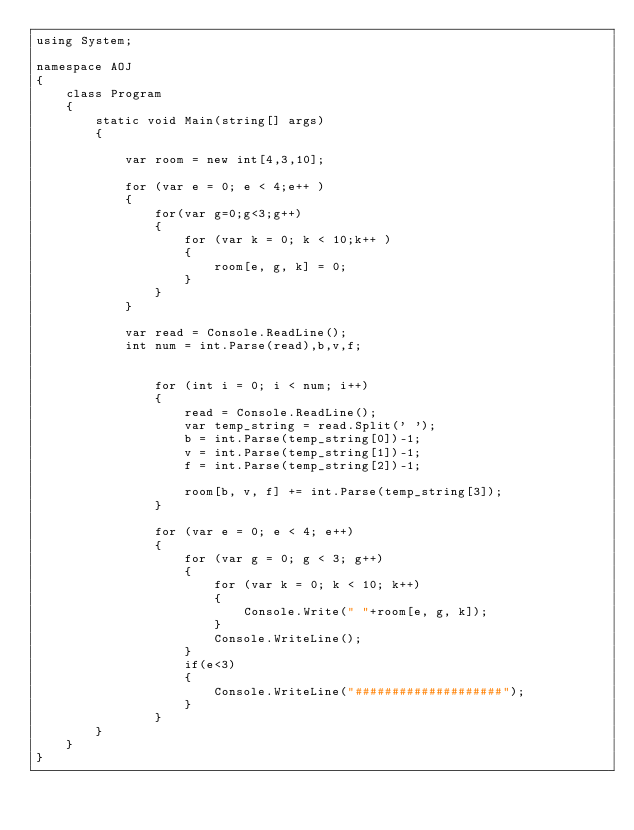Convert code to text. <code><loc_0><loc_0><loc_500><loc_500><_C#_>using System;

namespace AOJ
{
    class Program
    {
        static void Main(string[] args)
        {

            var room = new int[4,3,10];

            for (var e = 0; e < 4;e++ )
            {
                for(var g=0;g<3;g++)
                {
                    for (var k = 0; k < 10;k++ )
                    {
                        room[e, g, k] = 0;
                    }
                }
            }

            var read = Console.ReadLine();
            int num = int.Parse(read),b,v,f;


                for (int i = 0; i < num; i++)
                {
                    read = Console.ReadLine();
                    var temp_string = read.Split(' ');
                    b = int.Parse(temp_string[0])-1;
                    v = int.Parse(temp_string[1])-1;
                    f = int.Parse(temp_string[2])-1;

                    room[b, v, f] += int.Parse(temp_string[3]);
                }

                for (var e = 0; e < 4; e++)
                {
                    for (var g = 0; g < 3; g++)
                    {
                        for (var k = 0; k < 10; k++)
                        {
                            Console.Write(" "+room[e, g, k]);
                        }
                        Console.WriteLine();
                    }
                    if(e<3)
                    {
                        Console.WriteLine("####################");
                    }
                }
        }
    }
}</code> 